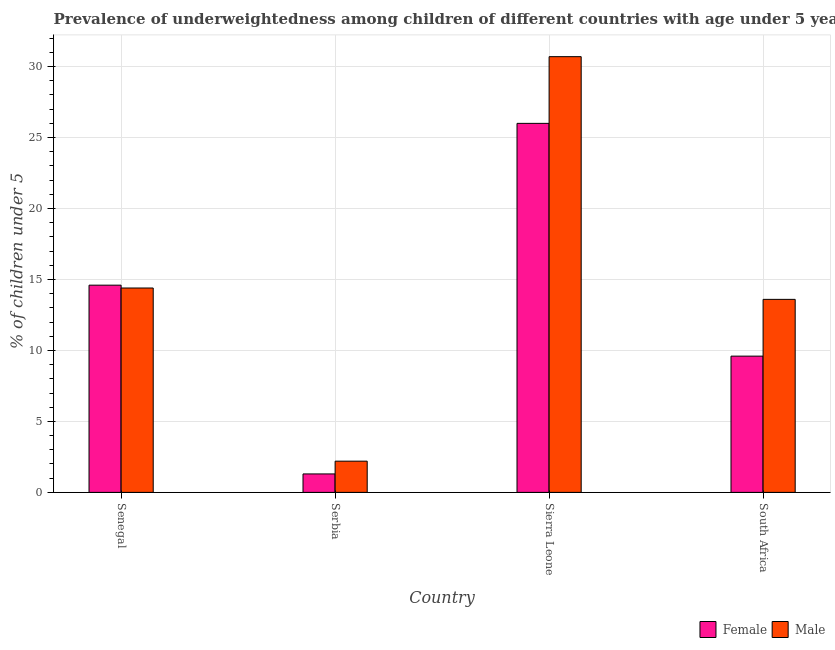How many groups of bars are there?
Your answer should be compact. 4. Are the number of bars on each tick of the X-axis equal?
Your answer should be compact. Yes. What is the label of the 3rd group of bars from the left?
Your response must be concise. Sierra Leone. In how many cases, is the number of bars for a given country not equal to the number of legend labels?
Ensure brevity in your answer.  0. What is the percentage of underweighted female children in Sierra Leone?
Provide a succinct answer. 26. Across all countries, what is the minimum percentage of underweighted male children?
Ensure brevity in your answer.  2.2. In which country was the percentage of underweighted male children maximum?
Your response must be concise. Sierra Leone. In which country was the percentage of underweighted male children minimum?
Make the answer very short. Serbia. What is the total percentage of underweighted female children in the graph?
Keep it short and to the point. 51.5. What is the difference between the percentage of underweighted female children in Senegal and that in South Africa?
Offer a terse response. 5. What is the difference between the percentage of underweighted male children in Serbia and the percentage of underweighted female children in South Africa?
Make the answer very short. -7.4. What is the average percentage of underweighted female children per country?
Your response must be concise. 12.88. What is the difference between the percentage of underweighted female children and percentage of underweighted male children in Sierra Leone?
Keep it short and to the point. -4.7. In how many countries, is the percentage of underweighted male children greater than 22 %?
Offer a terse response. 1. What is the ratio of the percentage of underweighted male children in Serbia to that in Sierra Leone?
Provide a succinct answer. 0.07. Is the percentage of underweighted female children in Senegal less than that in South Africa?
Give a very brief answer. No. What is the difference between the highest and the second highest percentage of underweighted male children?
Offer a terse response. 16.3. What is the difference between the highest and the lowest percentage of underweighted male children?
Offer a very short reply. 28.5. Is the sum of the percentage of underweighted male children in Serbia and Sierra Leone greater than the maximum percentage of underweighted female children across all countries?
Make the answer very short. Yes. What does the 1st bar from the left in Senegal represents?
Your response must be concise. Female. What does the 1st bar from the right in South Africa represents?
Provide a succinct answer. Male. How many bars are there?
Keep it short and to the point. 8. Are all the bars in the graph horizontal?
Your answer should be very brief. No. What is the difference between two consecutive major ticks on the Y-axis?
Make the answer very short. 5. Are the values on the major ticks of Y-axis written in scientific E-notation?
Offer a very short reply. No. Does the graph contain any zero values?
Make the answer very short. No. Does the graph contain grids?
Provide a succinct answer. Yes. How are the legend labels stacked?
Give a very brief answer. Horizontal. What is the title of the graph?
Your response must be concise. Prevalence of underweightedness among children of different countries with age under 5 years. Does "Passenger Transport Items" appear as one of the legend labels in the graph?
Your answer should be very brief. No. What is the label or title of the Y-axis?
Provide a succinct answer.  % of children under 5. What is the  % of children under 5 of Female in Senegal?
Offer a very short reply. 14.6. What is the  % of children under 5 of Male in Senegal?
Provide a short and direct response. 14.4. What is the  % of children under 5 of Female in Serbia?
Your answer should be compact. 1.3. What is the  % of children under 5 in Male in Serbia?
Ensure brevity in your answer.  2.2. What is the  % of children under 5 of Male in Sierra Leone?
Give a very brief answer. 30.7. What is the  % of children under 5 of Female in South Africa?
Your answer should be compact. 9.6. What is the  % of children under 5 of Male in South Africa?
Ensure brevity in your answer.  13.6. Across all countries, what is the maximum  % of children under 5 in Female?
Your answer should be compact. 26. Across all countries, what is the maximum  % of children under 5 in Male?
Make the answer very short. 30.7. Across all countries, what is the minimum  % of children under 5 in Female?
Provide a short and direct response. 1.3. Across all countries, what is the minimum  % of children under 5 of Male?
Offer a very short reply. 2.2. What is the total  % of children under 5 in Female in the graph?
Your answer should be very brief. 51.5. What is the total  % of children under 5 in Male in the graph?
Offer a terse response. 60.9. What is the difference between the  % of children under 5 in Male in Senegal and that in Serbia?
Your response must be concise. 12.2. What is the difference between the  % of children under 5 in Male in Senegal and that in Sierra Leone?
Give a very brief answer. -16.3. What is the difference between the  % of children under 5 in Female in Senegal and that in South Africa?
Keep it short and to the point. 5. What is the difference between the  % of children under 5 of Male in Senegal and that in South Africa?
Ensure brevity in your answer.  0.8. What is the difference between the  % of children under 5 of Female in Serbia and that in Sierra Leone?
Your answer should be compact. -24.7. What is the difference between the  % of children under 5 in Male in Serbia and that in Sierra Leone?
Provide a succinct answer. -28.5. What is the difference between the  % of children under 5 in Female in Senegal and the  % of children under 5 in Male in Sierra Leone?
Offer a very short reply. -16.1. What is the difference between the  % of children under 5 of Female in Senegal and the  % of children under 5 of Male in South Africa?
Keep it short and to the point. 1. What is the difference between the  % of children under 5 of Female in Serbia and the  % of children under 5 of Male in Sierra Leone?
Provide a succinct answer. -29.4. What is the difference between the  % of children under 5 in Female in Sierra Leone and the  % of children under 5 in Male in South Africa?
Offer a very short reply. 12.4. What is the average  % of children under 5 in Female per country?
Ensure brevity in your answer.  12.88. What is the average  % of children under 5 in Male per country?
Give a very brief answer. 15.22. What is the ratio of the  % of children under 5 of Female in Senegal to that in Serbia?
Ensure brevity in your answer.  11.23. What is the ratio of the  % of children under 5 in Male in Senegal to that in Serbia?
Provide a short and direct response. 6.55. What is the ratio of the  % of children under 5 in Female in Senegal to that in Sierra Leone?
Offer a terse response. 0.56. What is the ratio of the  % of children under 5 of Male in Senegal to that in Sierra Leone?
Provide a succinct answer. 0.47. What is the ratio of the  % of children under 5 of Female in Senegal to that in South Africa?
Your answer should be compact. 1.52. What is the ratio of the  % of children under 5 in Male in Senegal to that in South Africa?
Ensure brevity in your answer.  1.06. What is the ratio of the  % of children under 5 in Male in Serbia to that in Sierra Leone?
Make the answer very short. 0.07. What is the ratio of the  % of children under 5 in Female in Serbia to that in South Africa?
Your answer should be compact. 0.14. What is the ratio of the  % of children under 5 in Male in Serbia to that in South Africa?
Your answer should be compact. 0.16. What is the ratio of the  % of children under 5 of Female in Sierra Leone to that in South Africa?
Your answer should be very brief. 2.71. What is the ratio of the  % of children under 5 of Male in Sierra Leone to that in South Africa?
Offer a terse response. 2.26. What is the difference between the highest and the second highest  % of children under 5 of Female?
Provide a succinct answer. 11.4. What is the difference between the highest and the second highest  % of children under 5 of Male?
Your response must be concise. 16.3. What is the difference between the highest and the lowest  % of children under 5 in Female?
Ensure brevity in your answer.  24.7. 